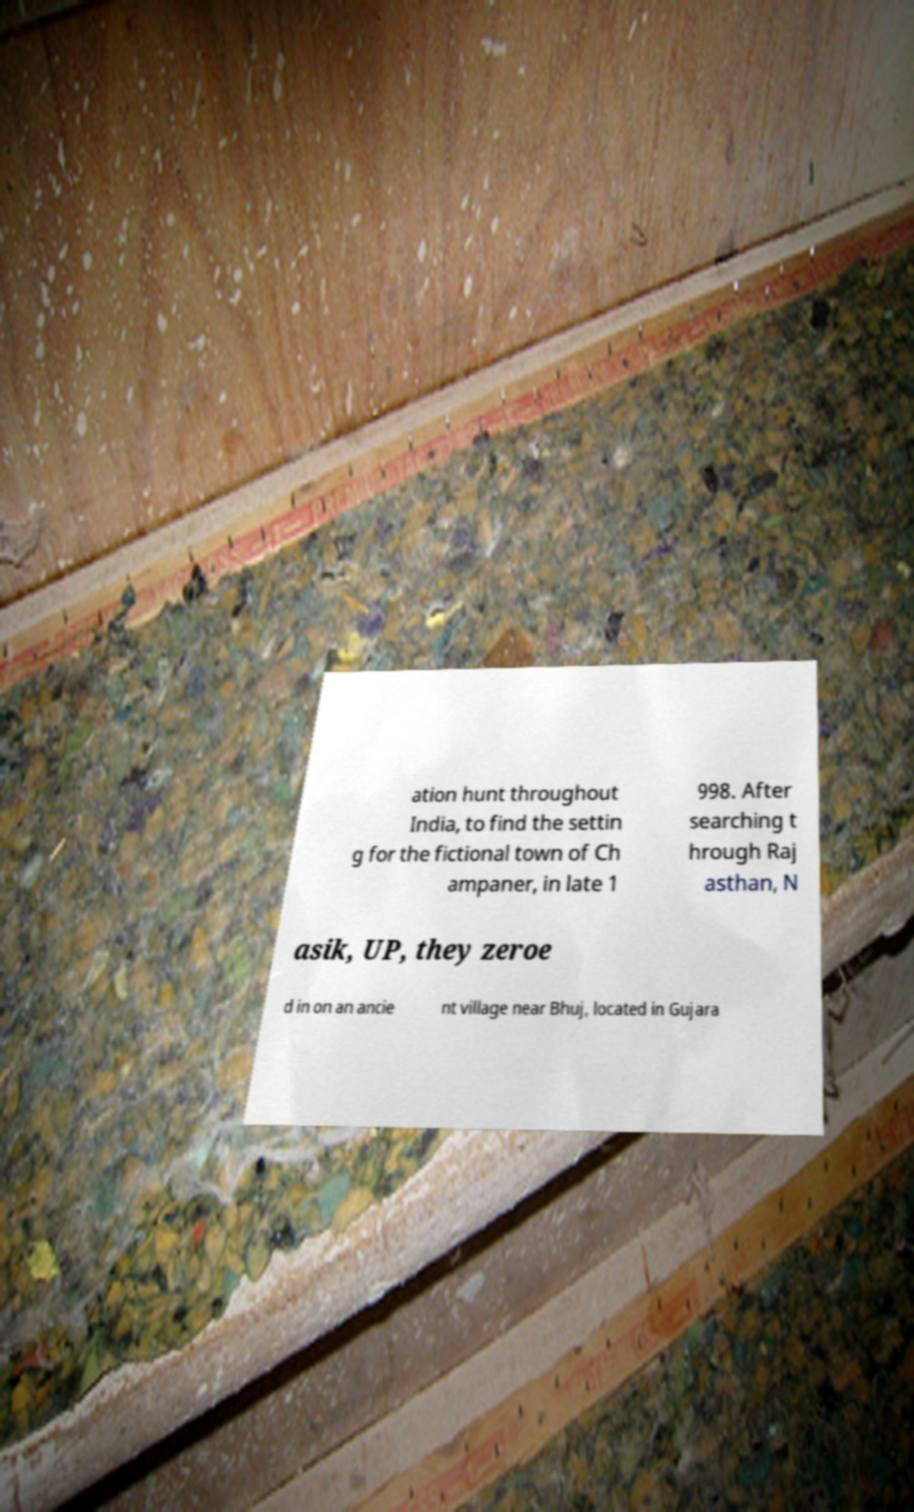Could you assist in decoding the text presented in this image and type it out clearly? ation hunt throughout India, to find the settin g for the fictional town of Ch ampaner, in late 1 998. After searching t hrough Raj asthan, N asik, UP, they zeroe d in on an ancie nt village near Bhuj, located in Gujara 